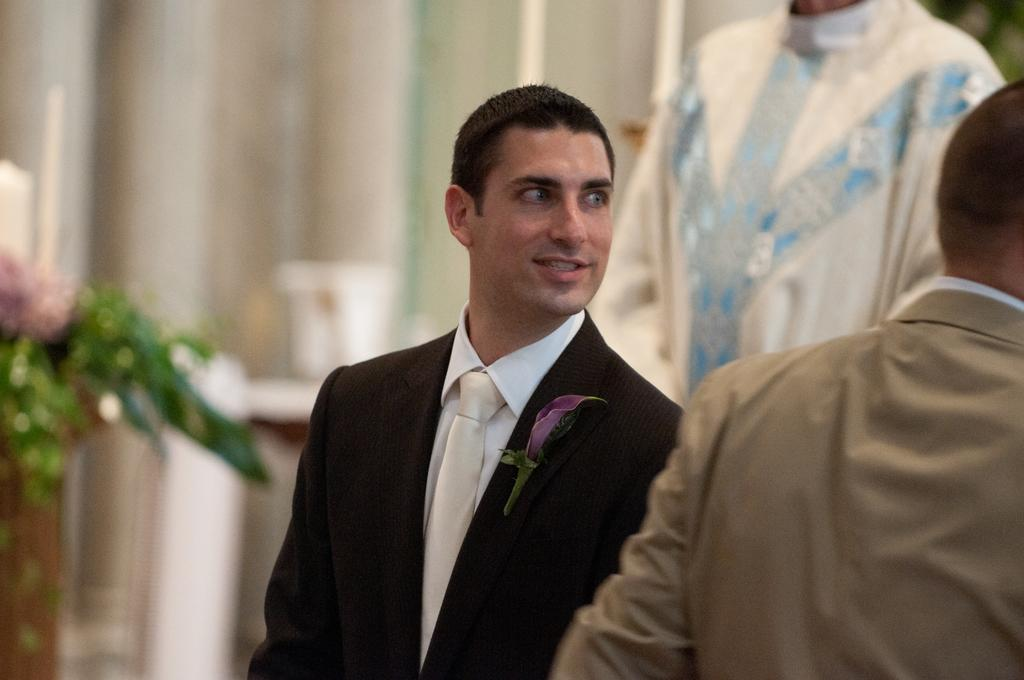How many people are in the image? There are people in the image, but the exact number is not specified. What can be observed about the people's clothing? The people are wearing different color dresses. What can be seen in the background of the image? There is a plant visible in the background. What is the color of the background? The background is white. How would you describe the quality of the image? The image is blurred. How many pigs are being carried by the porter in the image? There is no porter or pigs present in the image. Can you compare the size of the people in the image to the size of the pigs? There are no pigs in the image to compare the size of the people to. 